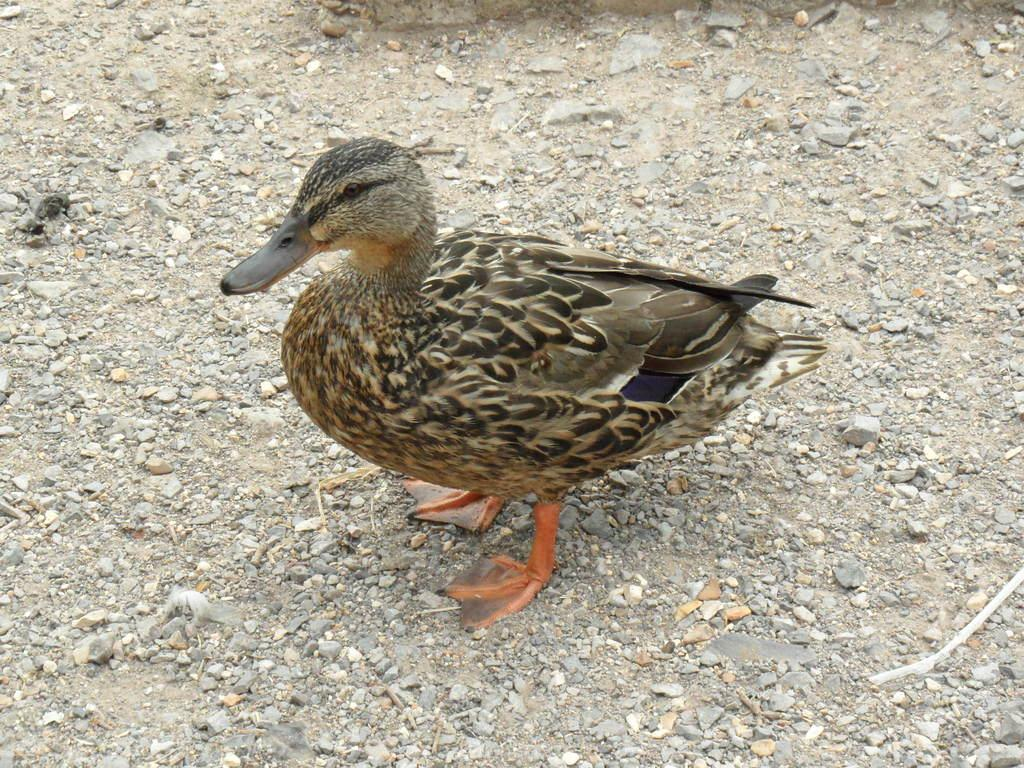What animal is present in the image? There is a duck in the picture. Can you describe the duck's appearance? The duck has brown and black feathers. What type of surface is visible on the floor? There is soil and rocks on the floor. What type of paste is being used by the duck in the image? There is no paste present in the image; it features a duck with brown and black feathers on a floor with soil and rocks. 